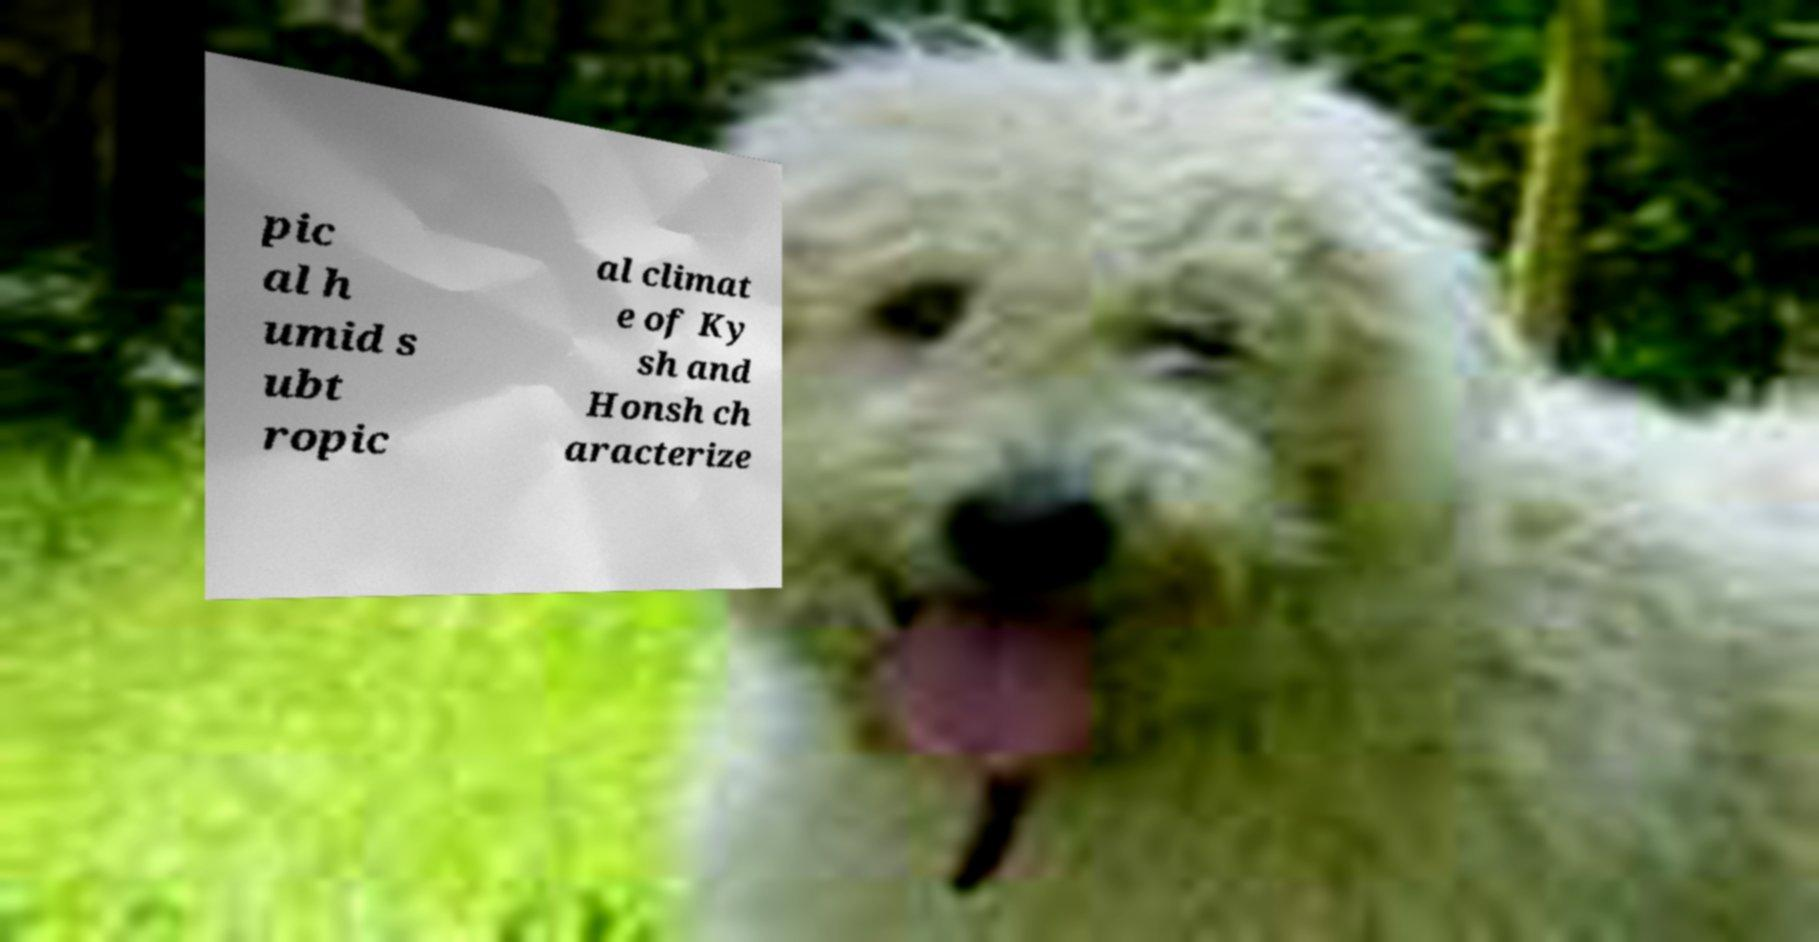Could you assist in decoding the text presented in this image and type it out clearly? pic al h umid s ubt ropic al climat e of Ky sh and Honsh ch aracterize 